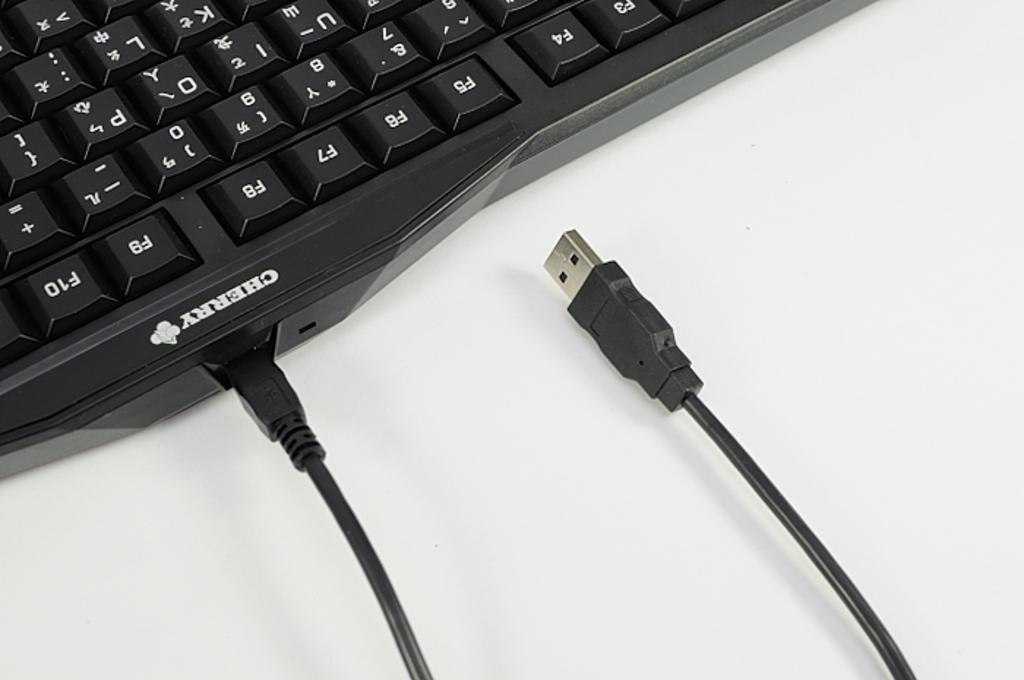<image>
Offer a succinct explanation of the picture presented. A keyboard that says Cherry right by the power cord port. 